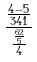<formula> <loc_0><loc_0><loc_500><loc_500>\frac { \frac { 4 - 5 } { 3 4 1 } } { \frac { \frac { 6 2 } { 5 } } { 4 } }</formula> 